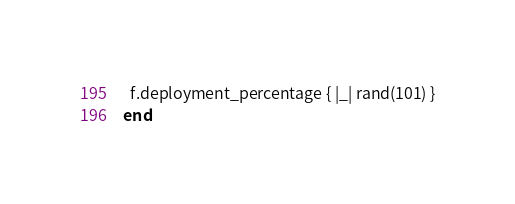<code> <loc_0><loc_0><loc_500><loc_500><_Ruby_>  f.deployment_percentage { |_| rand(101) }
end</code> 